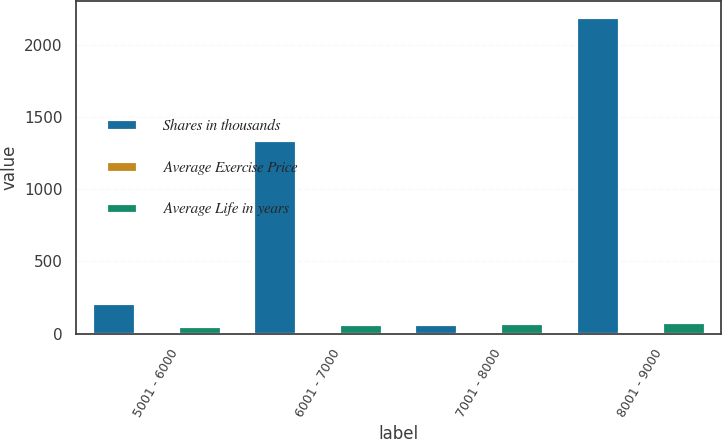Convert chart to OTSL. <chart><loc_0><loc_0><loc_500><loc_500><stacked_bar_chart><ecel><fcel>5001 - 6000<fcel>6001 - 7000<fcel>7001 - 8000<fcel>8001 - 9000<nl><fcel>Shares in thousands<fcel>211<fcel>1337<fcel>62.98<fcel>2189<nl><fcel>Average Exercise Price<fcel>6.35<fcel>1.2<fcel>3.19<fcel>3.33<nl><fcel>Average Life in years<fcel>55.83<fcel>62.98<fcel>71.47<fcel>80.92<nl></chart> 